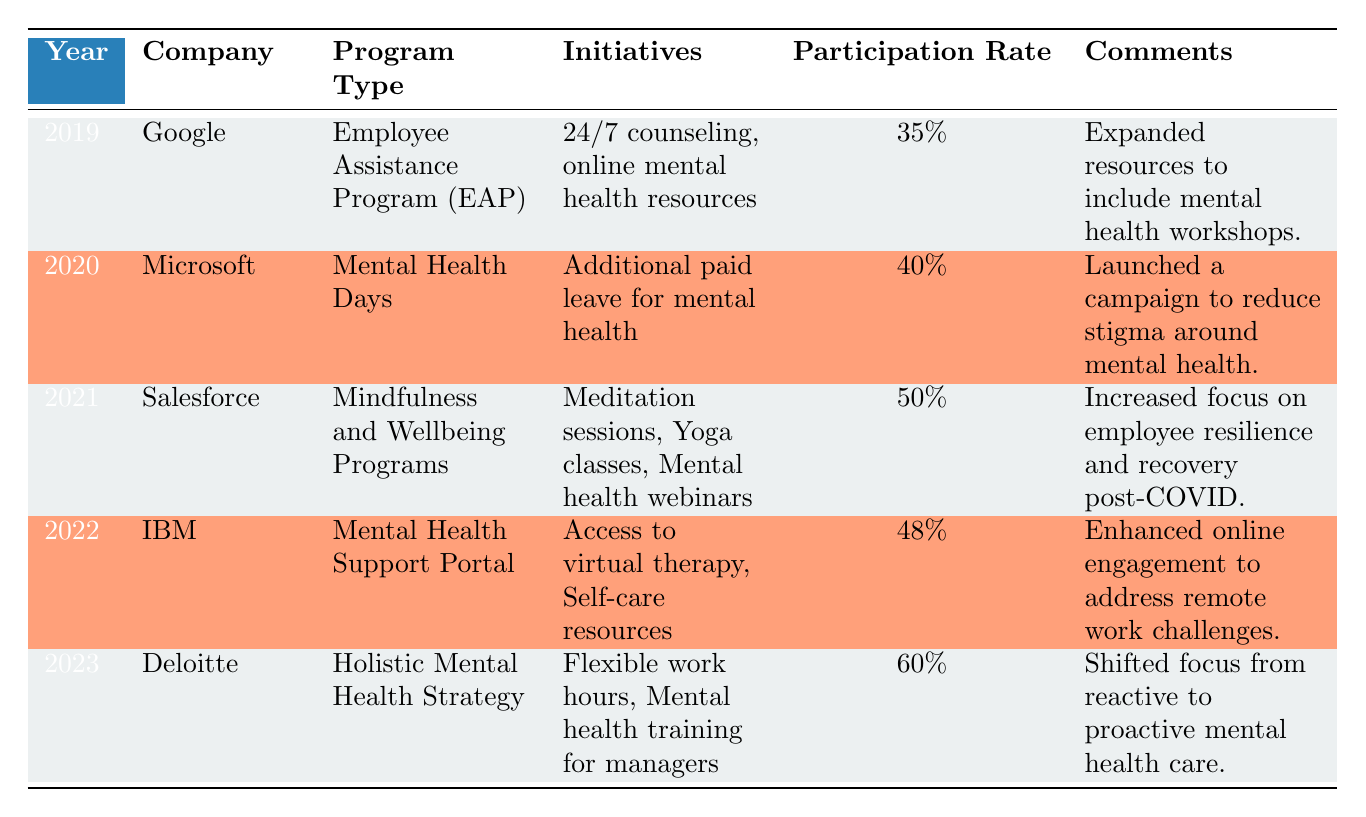What was the employee participation rate for Google in 2019? Referring to the table, Google had an employee participation rate of 35% in 2019.
Answer: 35% Which company implemented "Mindfulness and Wellbeing Programs" and in what year? The company that implemented "Mindfulness and Wellbeing Programs" was Salesforce, and this occurred in the year 2021.
Answer: Salesforce in 2021 What initiative was introduced by Microsoft to support mental health? Microsoft introduced "Additional paid leave for mental health" as an initiative in 2020 to support mental health.
Answer: Additional paid leave for mental health What is the difference in employee participation rates between Salesforce in 2021 and Deloitte in 2023? Salesforce had a participation rate of 50% in 2021, while Deloitte had a rate of 60% in 2023. The difference is 60% - 50% = 10%.
Answer: 10% Did IBM's Mental Health Support Portal include access to virtual therapy? Yes, the initiative for the Mental Health Support Portal included access to virtual therapy.
Answer: Yes How many companies had an employee participation rate of 40% or higher from 2019 to 2023? The companies that had a participation rate of 40% or higher are Microsoft (40%), Salesforce (50%), IBM (48%), and Deloitte (60%). That makes a total of 4 companies.
Answer: 4 What trend can be observed in the employee participation rates from 2019 to 2023? The trend shows that employee participation rates increased from 35% in 2019 to 60% in 2023, indicating a general improvement in mental health program engagement over these years.
Answer: Increasing Was there any initiative focused on training for managers within the mental health programs? Yes, Deloitte's program in 2023 included "Mental health training for managers" as one of its initiatives.
Answer: Yes What was the average employee participation rate for the years listed in the table? The participation rates are 35%, 40%, 50%, 48%, and 60%. Adding these gives 233%, and dividing by 5 gives an average of 46.6%.
Answer: 46.6% 